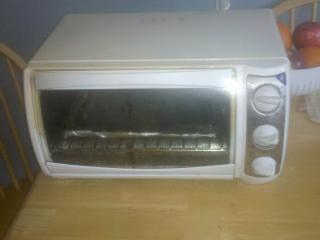<image>What are the two labeled items to the right of the appliance? I don't know what the two labeled items to the right of the appliance are. There are no clear labels. What brand is the toaster oven? It is unknown the brand of the toaster oven. It can be 'sunbeam', 'ge', 'oster', 'panasonic', 'hamilton beach' or 'toastmaster'. What brand is the toaster oven? I am not sure what brand the toaster oven is. What are the two labeled items to the right of the appliance? I don't know what the two labeled items to the right of the appliance are. It could be apple and orange, chair and wall, time and temperature, or something else. 